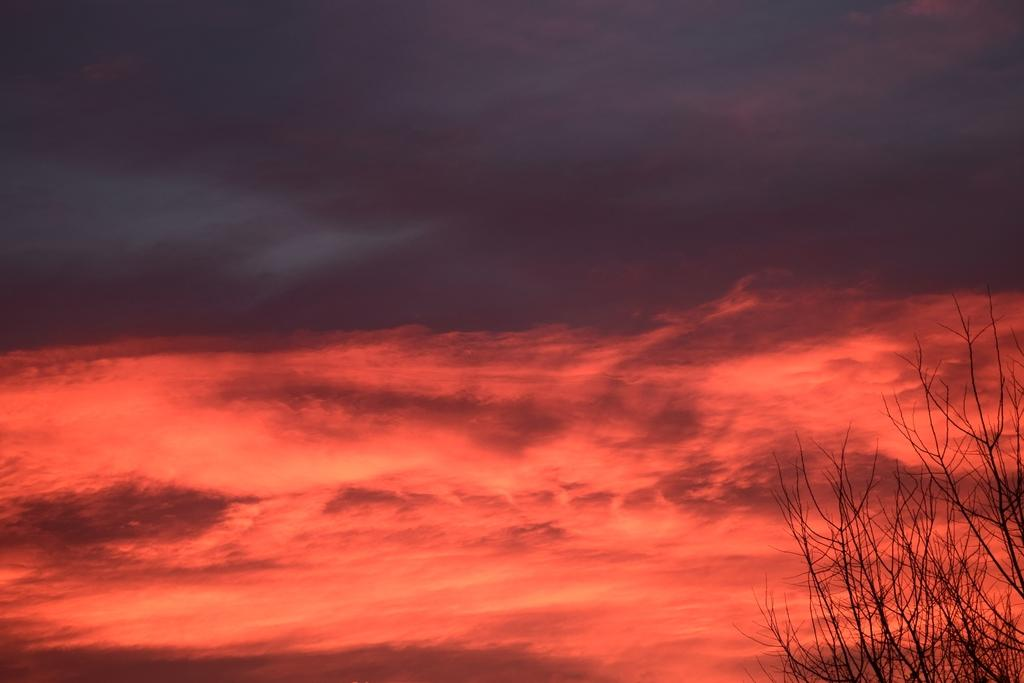What type of vegetation is on the right side of the image? There is a dry tree on the right side of the image. What is visible in the background of the image? The sky is visible in the background of the image. Who is the passenger of the dry tree in the image? There is no passenger associated with the dry tree in the image, as it is an inanimate object. 